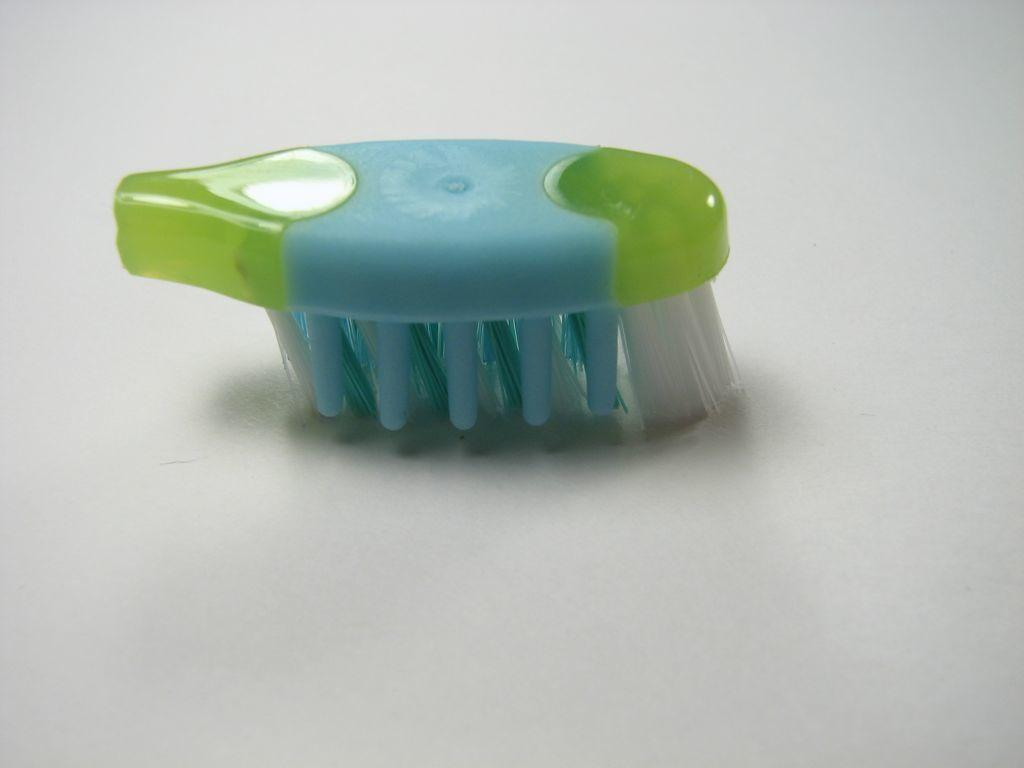What object is on the floor in the image? There is a toothbrush head on the floor in the image. What can be said about the color of the toothbrush head? The toothbrush head is blue and green in color. Where is the fan located in the image? There is no fan present in the image. What side of the room is the airport located on? There is no airport present in the image. 